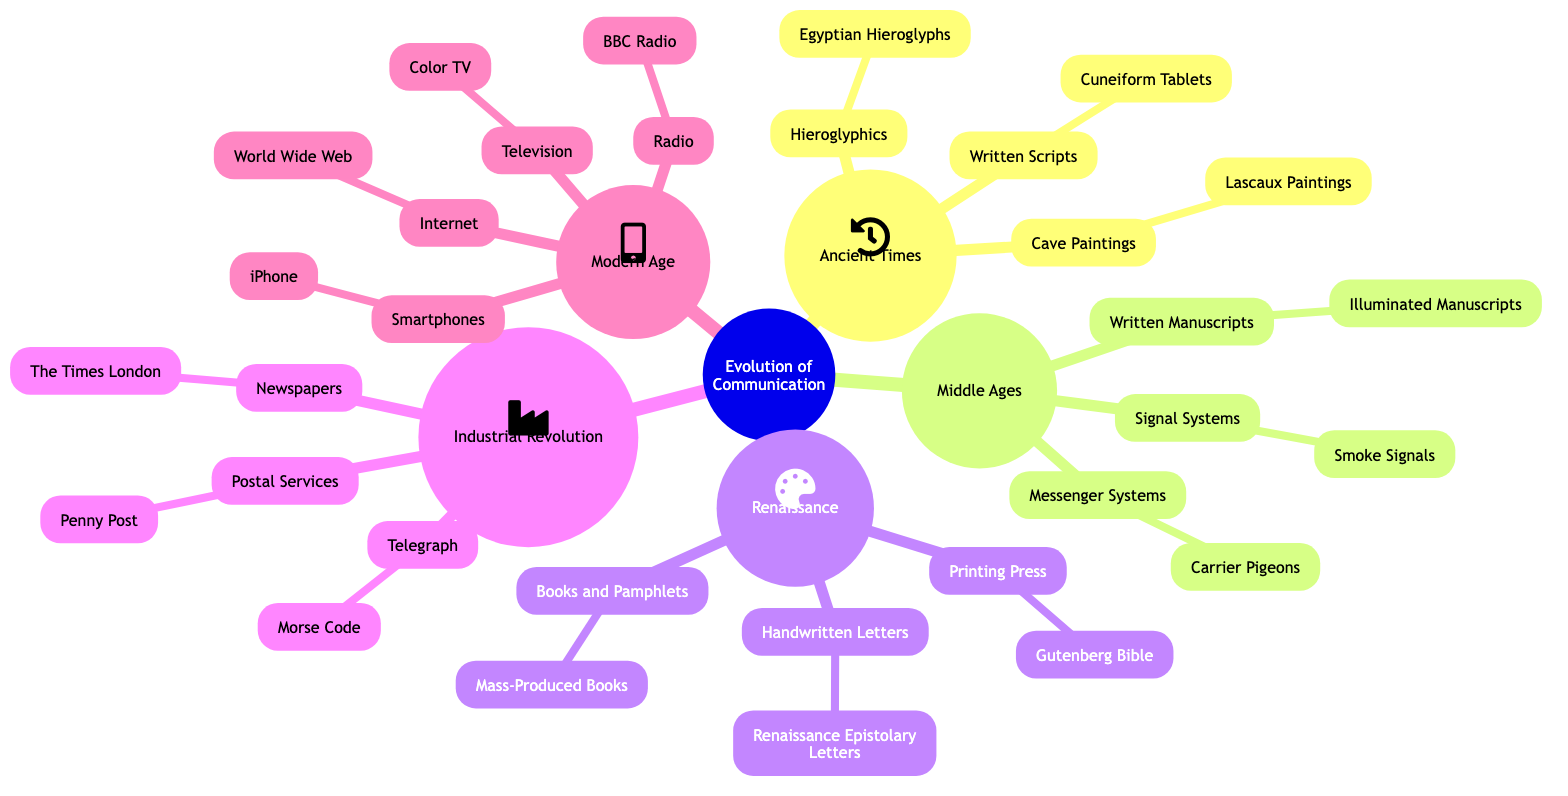What is the primary communication method in Ancient Times? The diagram indicates that the primary communication methods in Ancient Times include Cave Paintings, Hieroglyphics, and Written Scripts. The first mentioned is Cave Paintings.
Answer: Cave Paintings How many branches are under Modern Age? Under Modern Age in the diagram, there are four branches: Radio, Television, Internet, and Smartphones. Counting these branches gives a total of four.
Answer: 4 Which epoch follows the Middle Ages? The diagram displays the progression of epochs, and it shows that Renaissance follows Middle Ages.
Answer: Renaissance What is the relationship between the Telegraph and Morse Code? The diagram indicates that the Telegraph is a communication method from the Industrial Revolution and that it utilizes Morse Code as its specific technology. Thus, Morse Code is a form of the Telegraph.
Answer: Telegraph uses Morse Code Which communication method is associated with the printing press? Referring to the diagram, the Printing Press is linked with the Gutenberg Bible as its notable example or product.
Answer: Gutenberg Bible What era introduced the Internet as a communication method? The diagram categorizes the communication methods by epochs, stating that Internet is introduced during the Modern Age.
Answer: Modern Age How many specific communication methods are listed under the Renaissance? The Renaissance section of the diagram contains three specific communication methods: Printing Press, Handwritten Letters, and Books and Pamphlets. Thus, counting these, we have three methods listed.
Answer: 3 What communication technology is linked with Carrier Pigeons? The Carrier Pigeons are categorized under Messenger Systems within the Middle Ages. Hence, Messenger Systems is the broader category that includes Carrier Pigeons.
Answer: Messenger Systems Which specific method is connected to Smoke Signals? The diagram categorizes Smoke Signals under Signal Systems in the Middle Ages. Therefore, Signal Systems is the communication method associated with Smoke Signals.
Answer: Signal Systems 